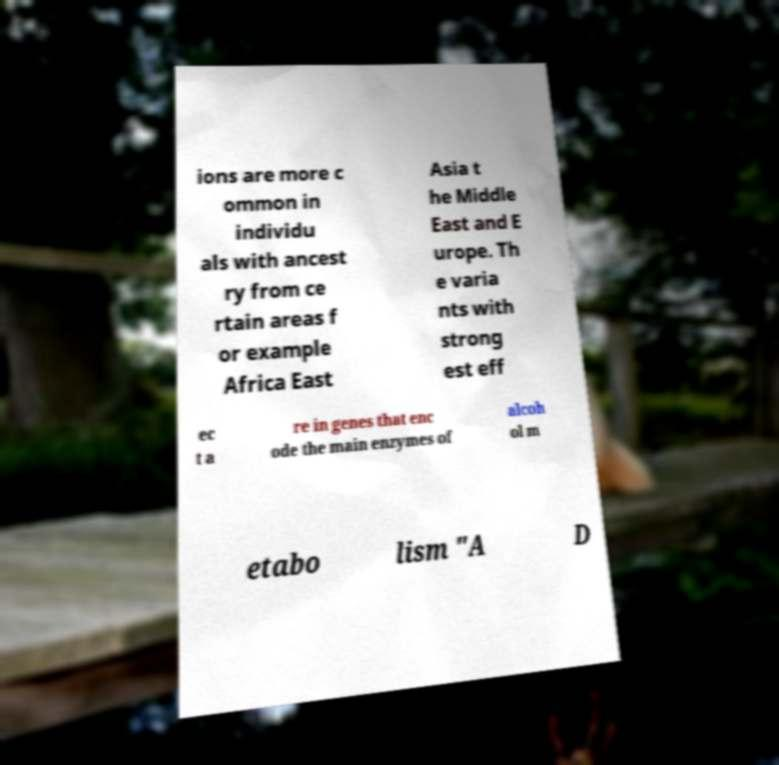I need the written content from this picture converted into text. Can you do that? ions are more c ommon in individu als with ancest ry from ce rtain areas f or example Africa East Asia t he Middle East and E urope. Th e varia nts with strong est eff ec t a re in genes that enc ode the main enzymes of alcoh ol m etabo lism "A D 